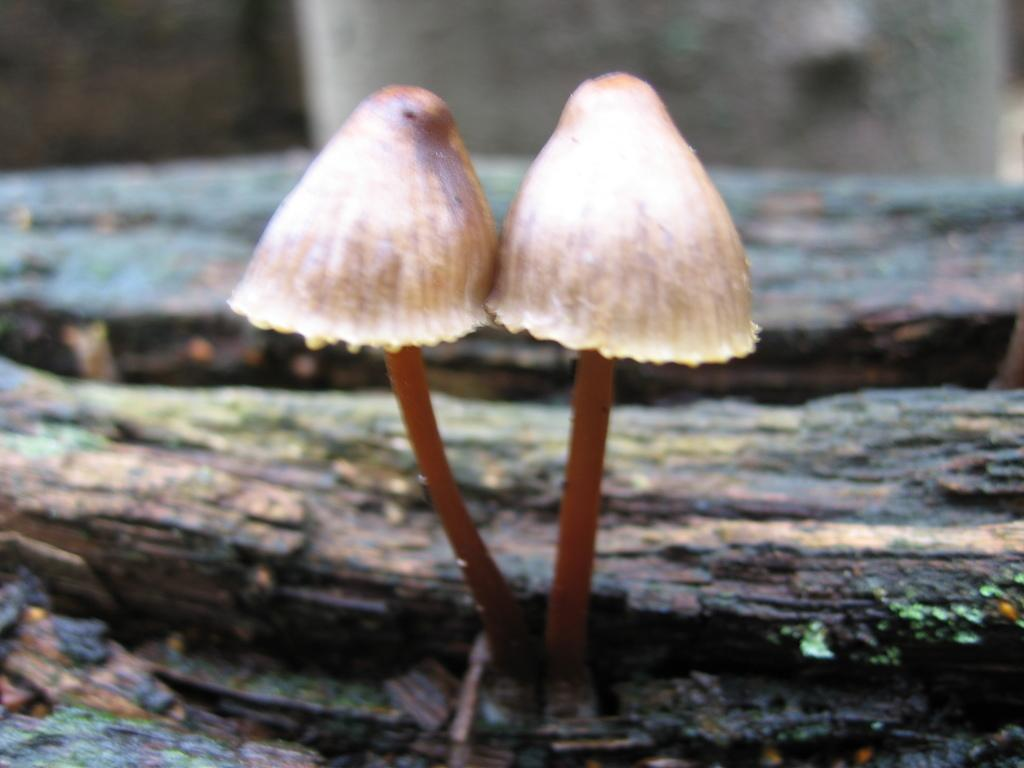How many mushrooms are present in the image? There are two mushrooms in the picture. Can you describe the background of the mushrooms? The background of the mushrooms is blurred. What type of tools does the carpenter use in the image? There is no carpenter present in the image; it features two mushrooms with a blurred background. What instrument is the drummer playing in the image? There is no drummer or drum present in the image; it features two mushrooms with a blurred background. 